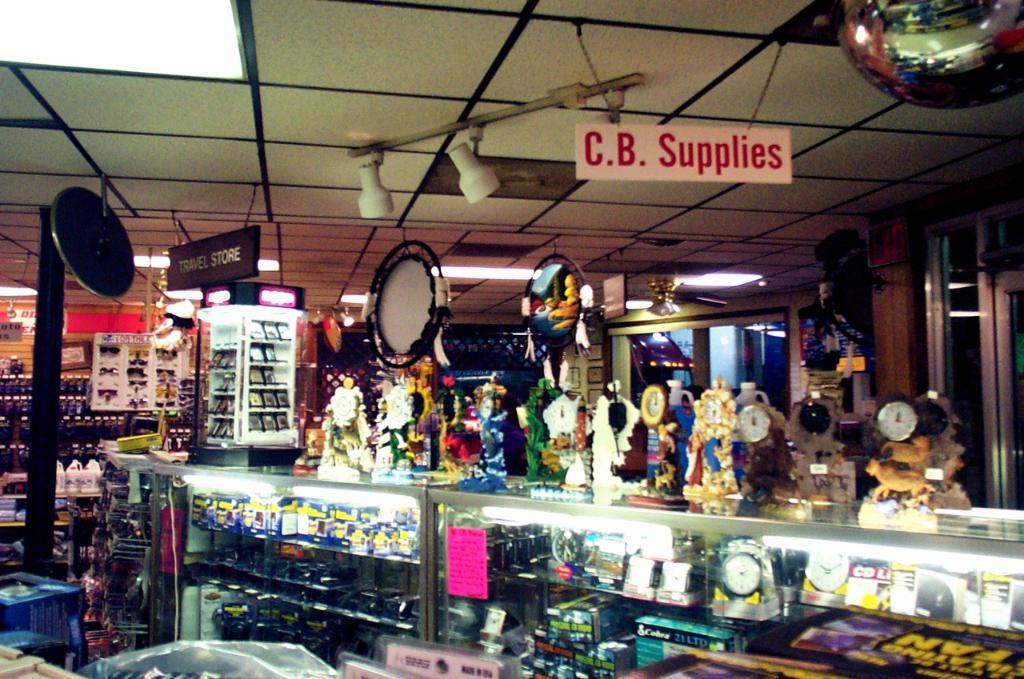<image>
Relay a brief, clear account of the picture shown. A sign hanging from the ceiling in a shop says C.B. Supplies. 